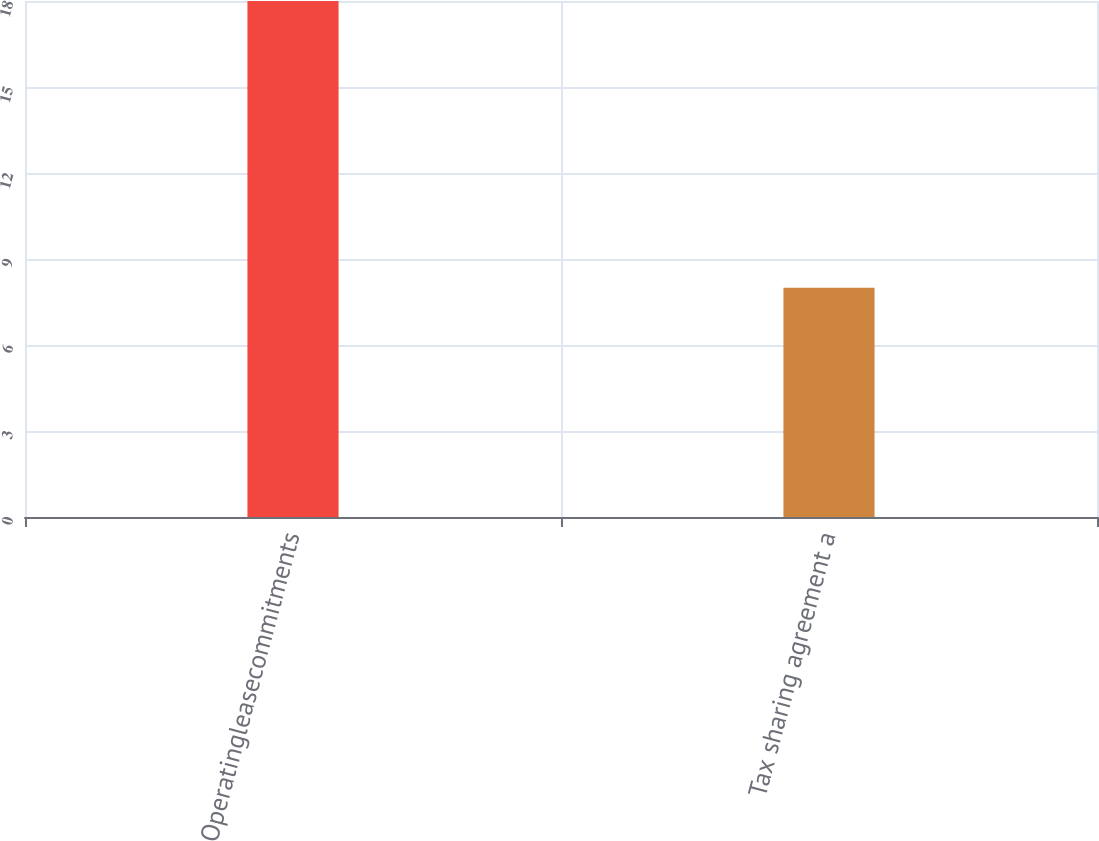Convert chart. <chart><loc_0><loc_0><loc_500><loc_500><bar_chart><fcel>Operatingleasecommitments<fcel>Tax sharing agreement a<nl><fcel>18<fcel>8<nl></chart> 